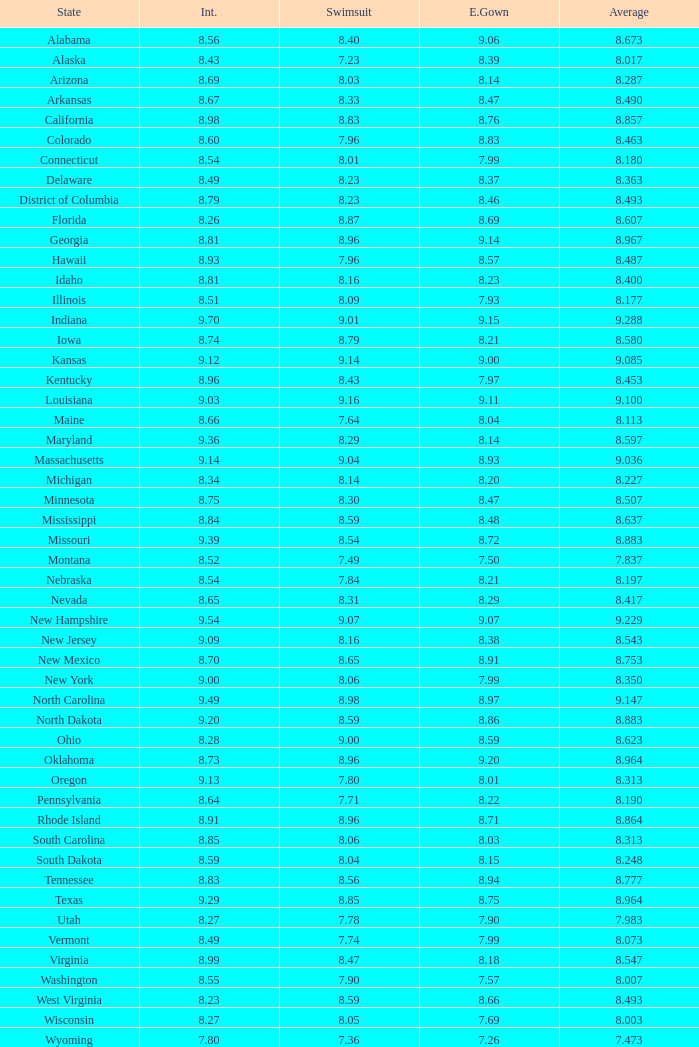Name the state with an evening gown more than 8.86 and interview less than 8.7 and swimsuit less than 8.96 Alabama. 